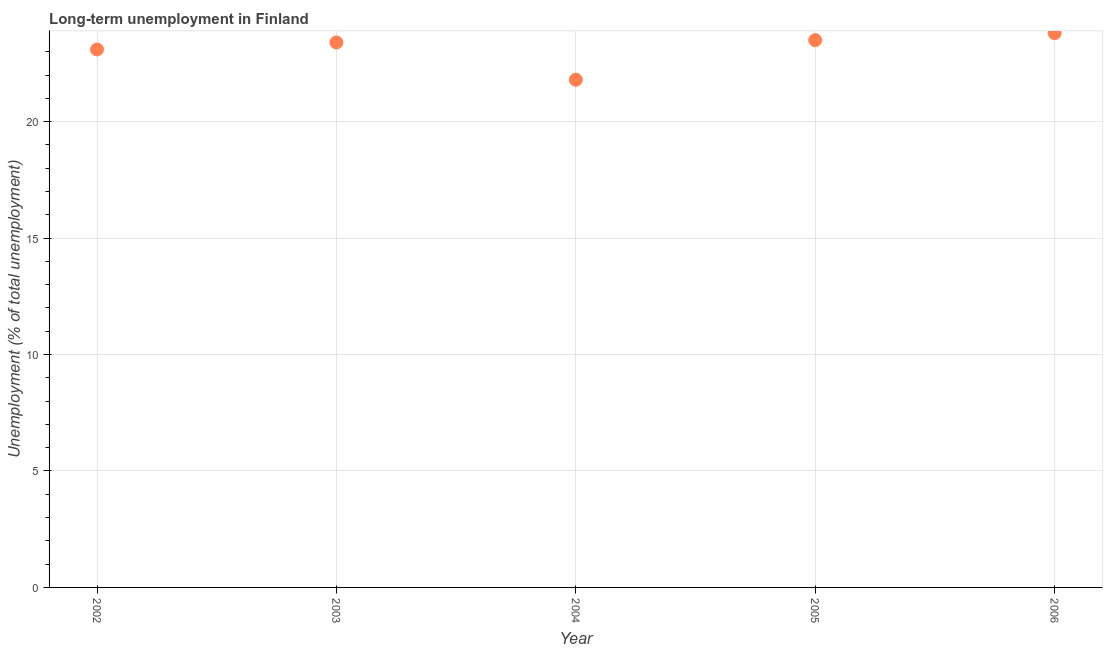What is the long-term unemployment in 2005?
Your answer should be compact. 23.5. Across all years, what is the maximum long-term unemployment?
Your response must be concise. 23.8. Across all years, what is the minimum long-term unemployment?
Ensure brevity in your answer.  21.8. In which year was the long-term unemployment maximum?
Your answer should be compact. 2006. In which year was the long-term unemployment minimum?
Offer a terse response. 2004. What is the sum of the long-term unemployment?
Give a very brief answer. 115.6. What is the difference between the long-term unemployment in 2002 and 2003?
Provide a short and direct response. -0.3. What is the average long-term unemployment per year?
Ensure brevity in your answer.  23.12. What is the median long-term unemployment?
Make the answer very short. 23.4. In how many years, is the long-term unemployment greater than 16 %?
Give a very brief answer. 5. Do a majority of the years between 2003 and 2002 (inclusive) have long-term unemployment greater than 17 %?
Provide a short and direct response. No. What is the ratio of the long-term unemployment in 2003 to that in 2004?
Keep it short and to the point. 1.07. Is the long-term unemployment in 2002 less than that in 2003?
Offer a terse response. Yes. Is the difference between the long-term unemployment in 2002 and 2003 greater than the difference between any two years?
Offer a terse response. No. What is the difference between the highest and the second highest long-term unemployment?
Make the answer very short. 0.3. What is the difference between the highest and the lowest long-term unemployment?
Offer a terse response. 2. Does the long-term unemployment monotonically increase over the years?
Offer a very short reply. No. How many dotlines are there?
Your answer should be compact. 1. How many years are there in the graph?
Your answer should be very brief. 5. What is the difference between two consecutive major ticks on the Y-axis?
Provide a succinct answer. 5. Are the values on the major ticks of Y-axis written in scientific E-notation?
Your response must be concise. No. What is the title of the graph?
Offer a terse response. Long-term unemployment in Finland. What is the label or title of the Y-axis?
Give a very brief answer. Unemployment (% of total unemployment). What is the Unemployment (% of total unemployment) in 2002?
Make the answer very short. 23.1. What is the Unemployment (% of total unemployment) in 2003?
Provide a short and direct response. 23.4. What is the Unemployment (% of total unemployment) in 2004?
Ensure brevity in your answer.  21.8. What is the Unemployment (% of total unemployment) in 2005?
Keep it short and to the point. 23.5. What is the Unemployment (% of total unemployment) in 2006?
Give a very brief answer. 23.8. What is the difference between the Unemployment (% of total unemployment) in 2002 and 2004?
Ensure brevity in your answer.  1.3. What is the difference between the Unemployment (% of total unemployment) in 2003 and 2004?
Provide a succinct answer. 1.6. What is the difference between the Unemployment (% of total unemployment) in 2003 and 2005?
Your response must be concise. -0.1. What is the difference between the Unemployment (% of total unemployment) in 2004 and 2005?
Offer a terse response. -1.7. What is the difference between the Unemployment (% of total unemployment) in 2005 and 2006?
Your answer should be compact. -0.3. What is the ratio of the Unemployment (% of total unemployment) in 2002 to that in 2004?
Provide a succinct answer. 1.06. What is the ratio of the Unemployment (% of total unemployment) in 2002 to that in 2006?
Make the answer very short. 0.97. What is the ratio of the Unemployment (% of total unemployment) in 2003 to that in 2004?
Give a very brief answer. 1.07. What is the ratio of the Unemployment (% of total unemployment) in 2004 to that in 2005?
Your response must be concise. 0.93. What is the ratio of the Unemployment (% of total unemployment) in 2004 to that in 2006?
Give a very brief answer. 0.92. What is the ratio of the Unemployment (% of total unemployment) in 2005 to that in 2006?
Ensure brevity in your answer.  0.99. 